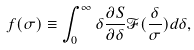Convert formula to latex. <formula><loc_0><loc_0><loc_500><loc_500>f ( \sigma ) \equiv \int _ { 0 } ^ { \infty } \delta \frac { \partial S } { \partial \delta } \mathcal { F } ( \frac { \delta } { \sigma } ) d \delta ,</formula> 